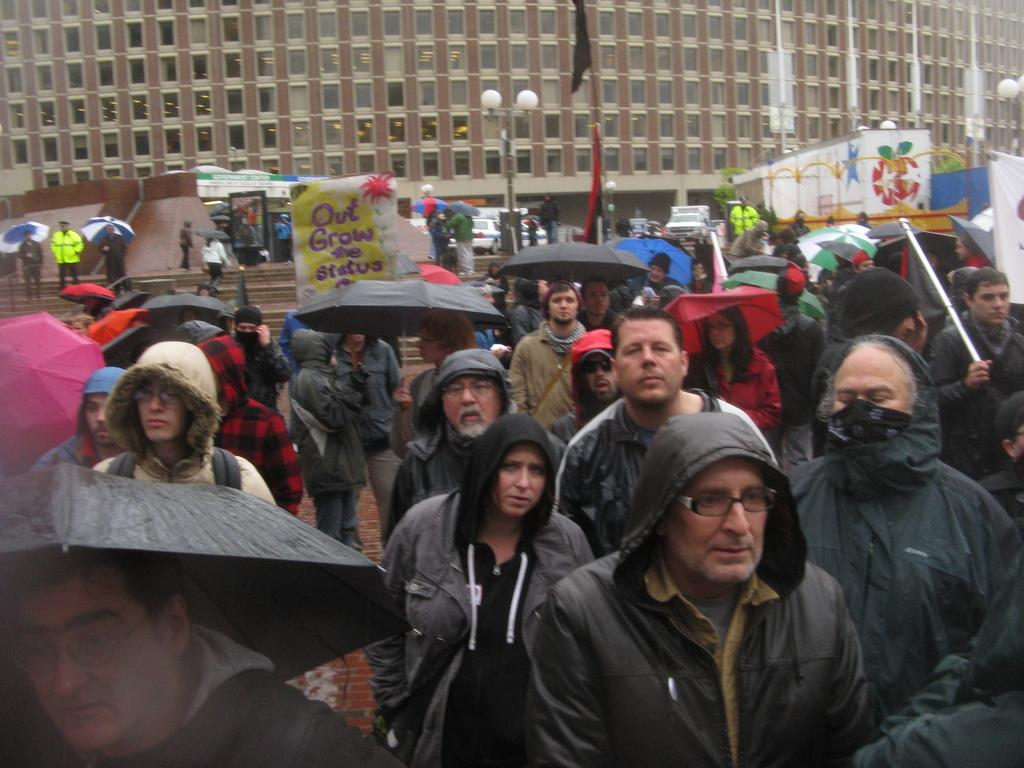What is happening on the road in the image? There is a group of persons on the road in the image. What can be seen in the background of the image? In the background of the image, there are stairs, a light pole, vehicles, and a building. What channel is the camera tuned to in the image? There is no camera present in the image, so it is not possible to determine what channel it might be tuned to. 